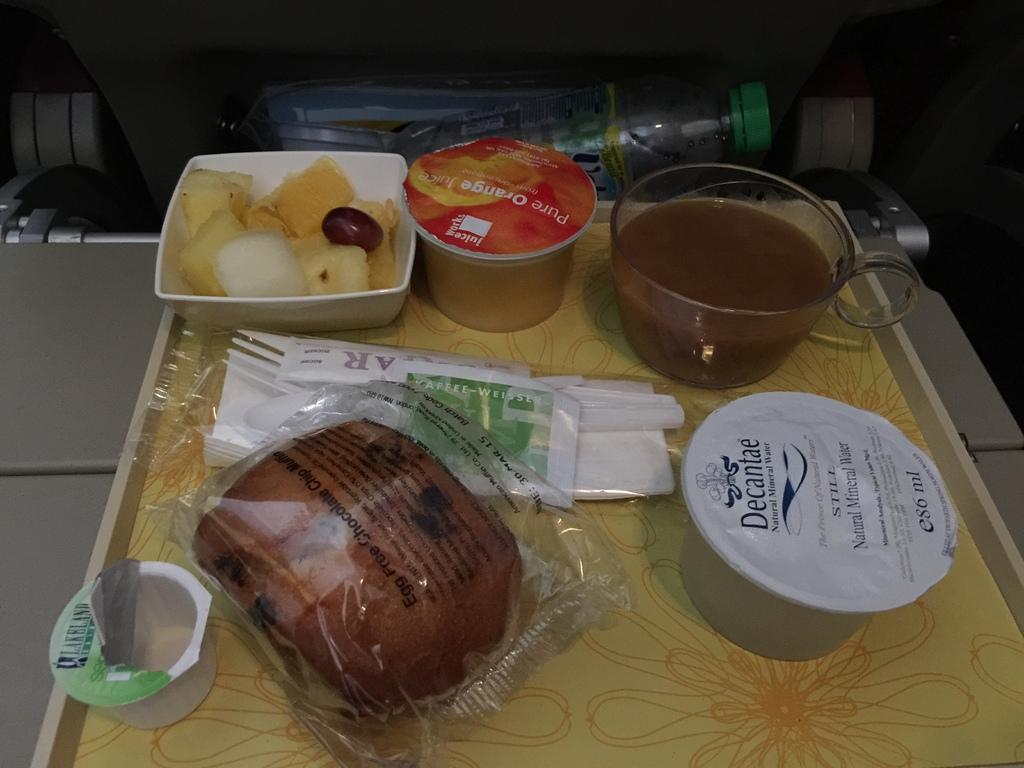What is placed on the tray in the image? There are food items placed on a tray in the image. Can you describe anything else visible in the image? There are waste items visible behind the tray in the image. How many pets can be seen wearing vests in the image? There are no pets or vests present in the image. What type of mice are interacting with the food items on the tray? There are no mice present in the image; it only shows food items on a tray and waste items behind it. 